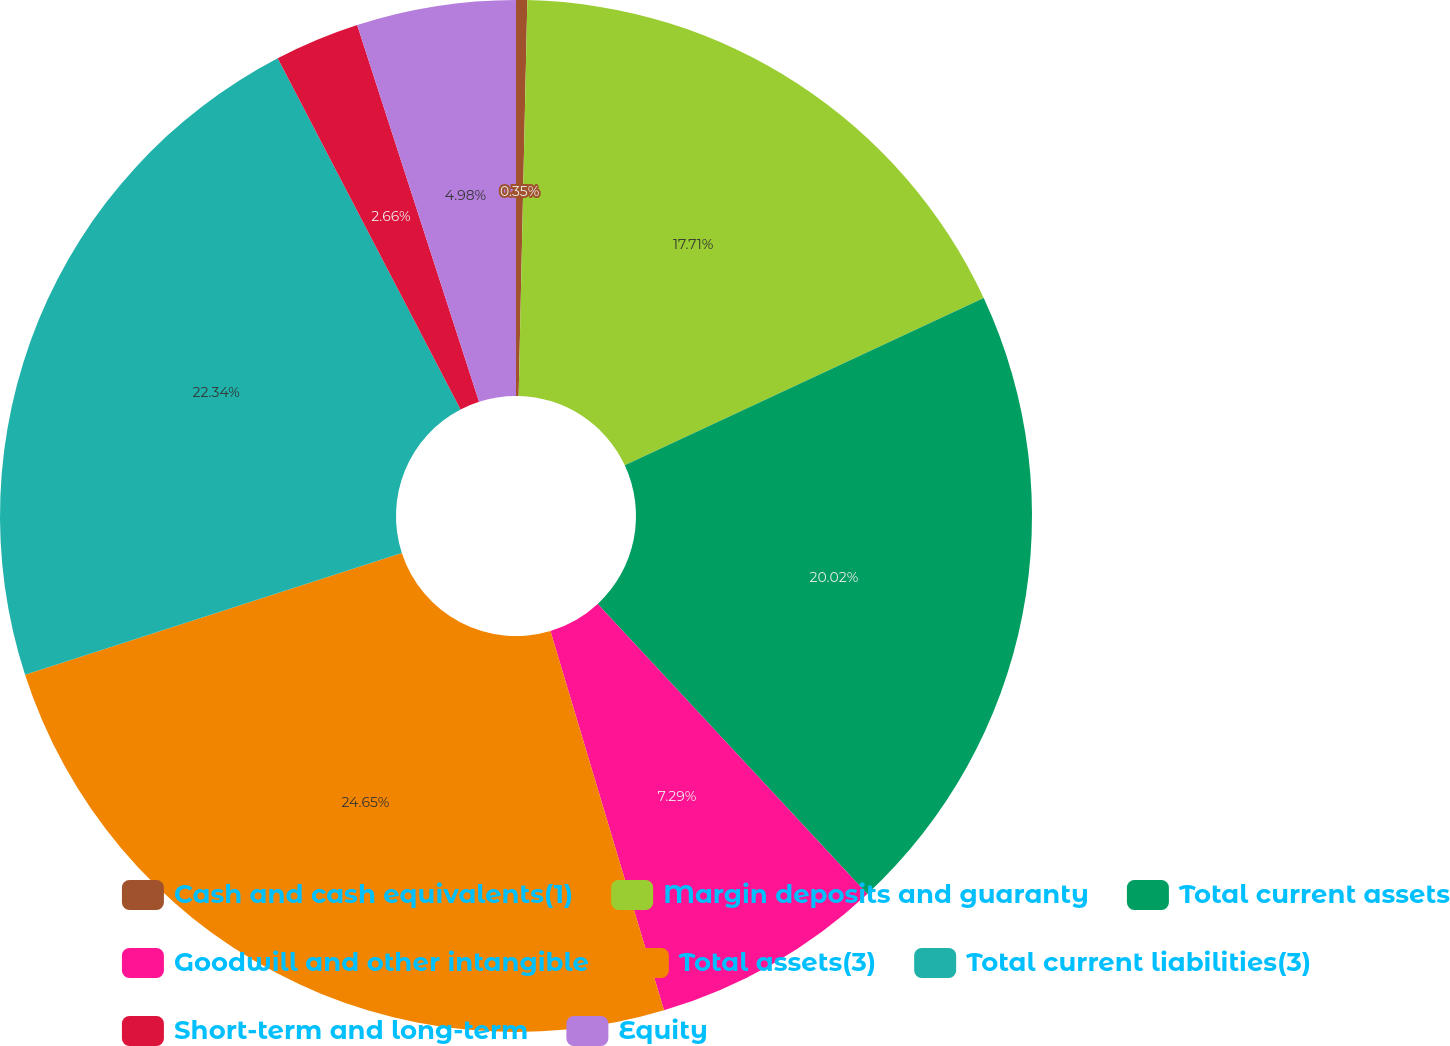Convert chart. <chart><loc_0><loc_0><loc_500><loc_500><pie_chart><fcel>Cash and cash equivalents(1)<fcel>Margin deposits and guaranty<fcel>Total current assets<fcel>Goodwill and other intangible<fcel>Total assets(3)<fcel>Total current liabilities(3)<fcel>Short-term and long-term<fcel>Equity<nl><fcel>0.35%<fcel>17.71%<fcel>20.02%<fcel>7.29%<fcel>24.65%<fcel>22.34%<fcel>2.66%<fcel>4.98%<nl></chart> 